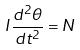Convert formula to latex. <formula><loc_0><loc_0><loc_500><loc_500>I \frac { d ^ { 2 } \theta } { d t ^ { 2 } } = N</formula> 